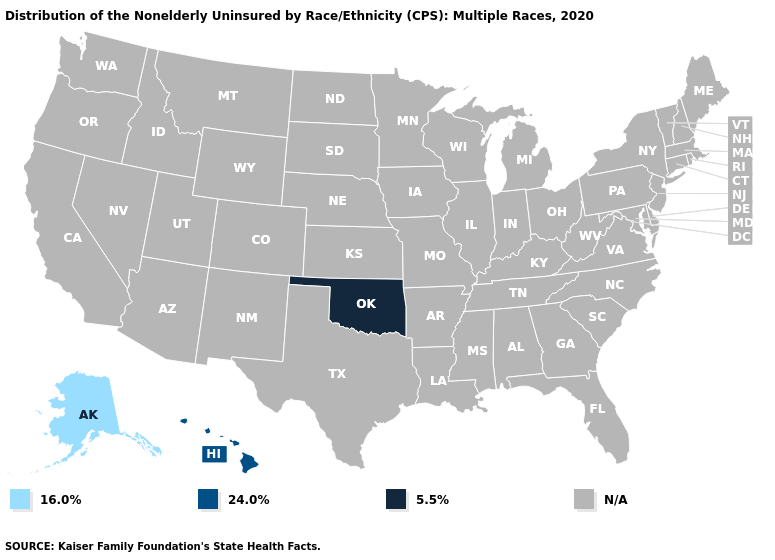Name the states that have a value in the range 16.0%?
Be succinct. Alaska. Name the states that have a value in the range N/A?
Keep it brief. Alabama, Arizona, Arkansas, California, Colorado, Connecticut, Delaware, Florida, Georgia, Idaho, Illinois, Indiana, Iowa, Kansas, Kentucky, Louisiana, Maine, Maryland, Massachusetts, Michigan, Minnesota, Mississippi, Missouri, Montana, Nebraska, Nevada, New Hampshire, New Jersey, New Mexico, New York, North Carolina, North Dakota, Ohio, Oregon, Pennsylvania, Rhode Island, South Carolina, South Dakota, Tennessee, Texas, Utah, Vermont, Virginia, Washington, West Virginia, Wisconsin, Wyoming. Name the states that have a value in the range 5.5%?
Short answer required. Oklahoma. Does the first symbol in the legend represent the smallest category?
Answer briefly. Yes. How many symbols are there in the legend?
Give a very brief answer. 4. What is the value of Wyoming?
Answer briefly. N/A. Does the first symbol in the legend represent the smallest category?
Write a very short answer. Yes. Name the states that have a value in the range 5.5%?
Keep it brief. Oklahoma. What is the value of Maryland?
Short answer required. N/A. Name the states that have a value in the range 16.0%?
Quick response, please. Alaska. 